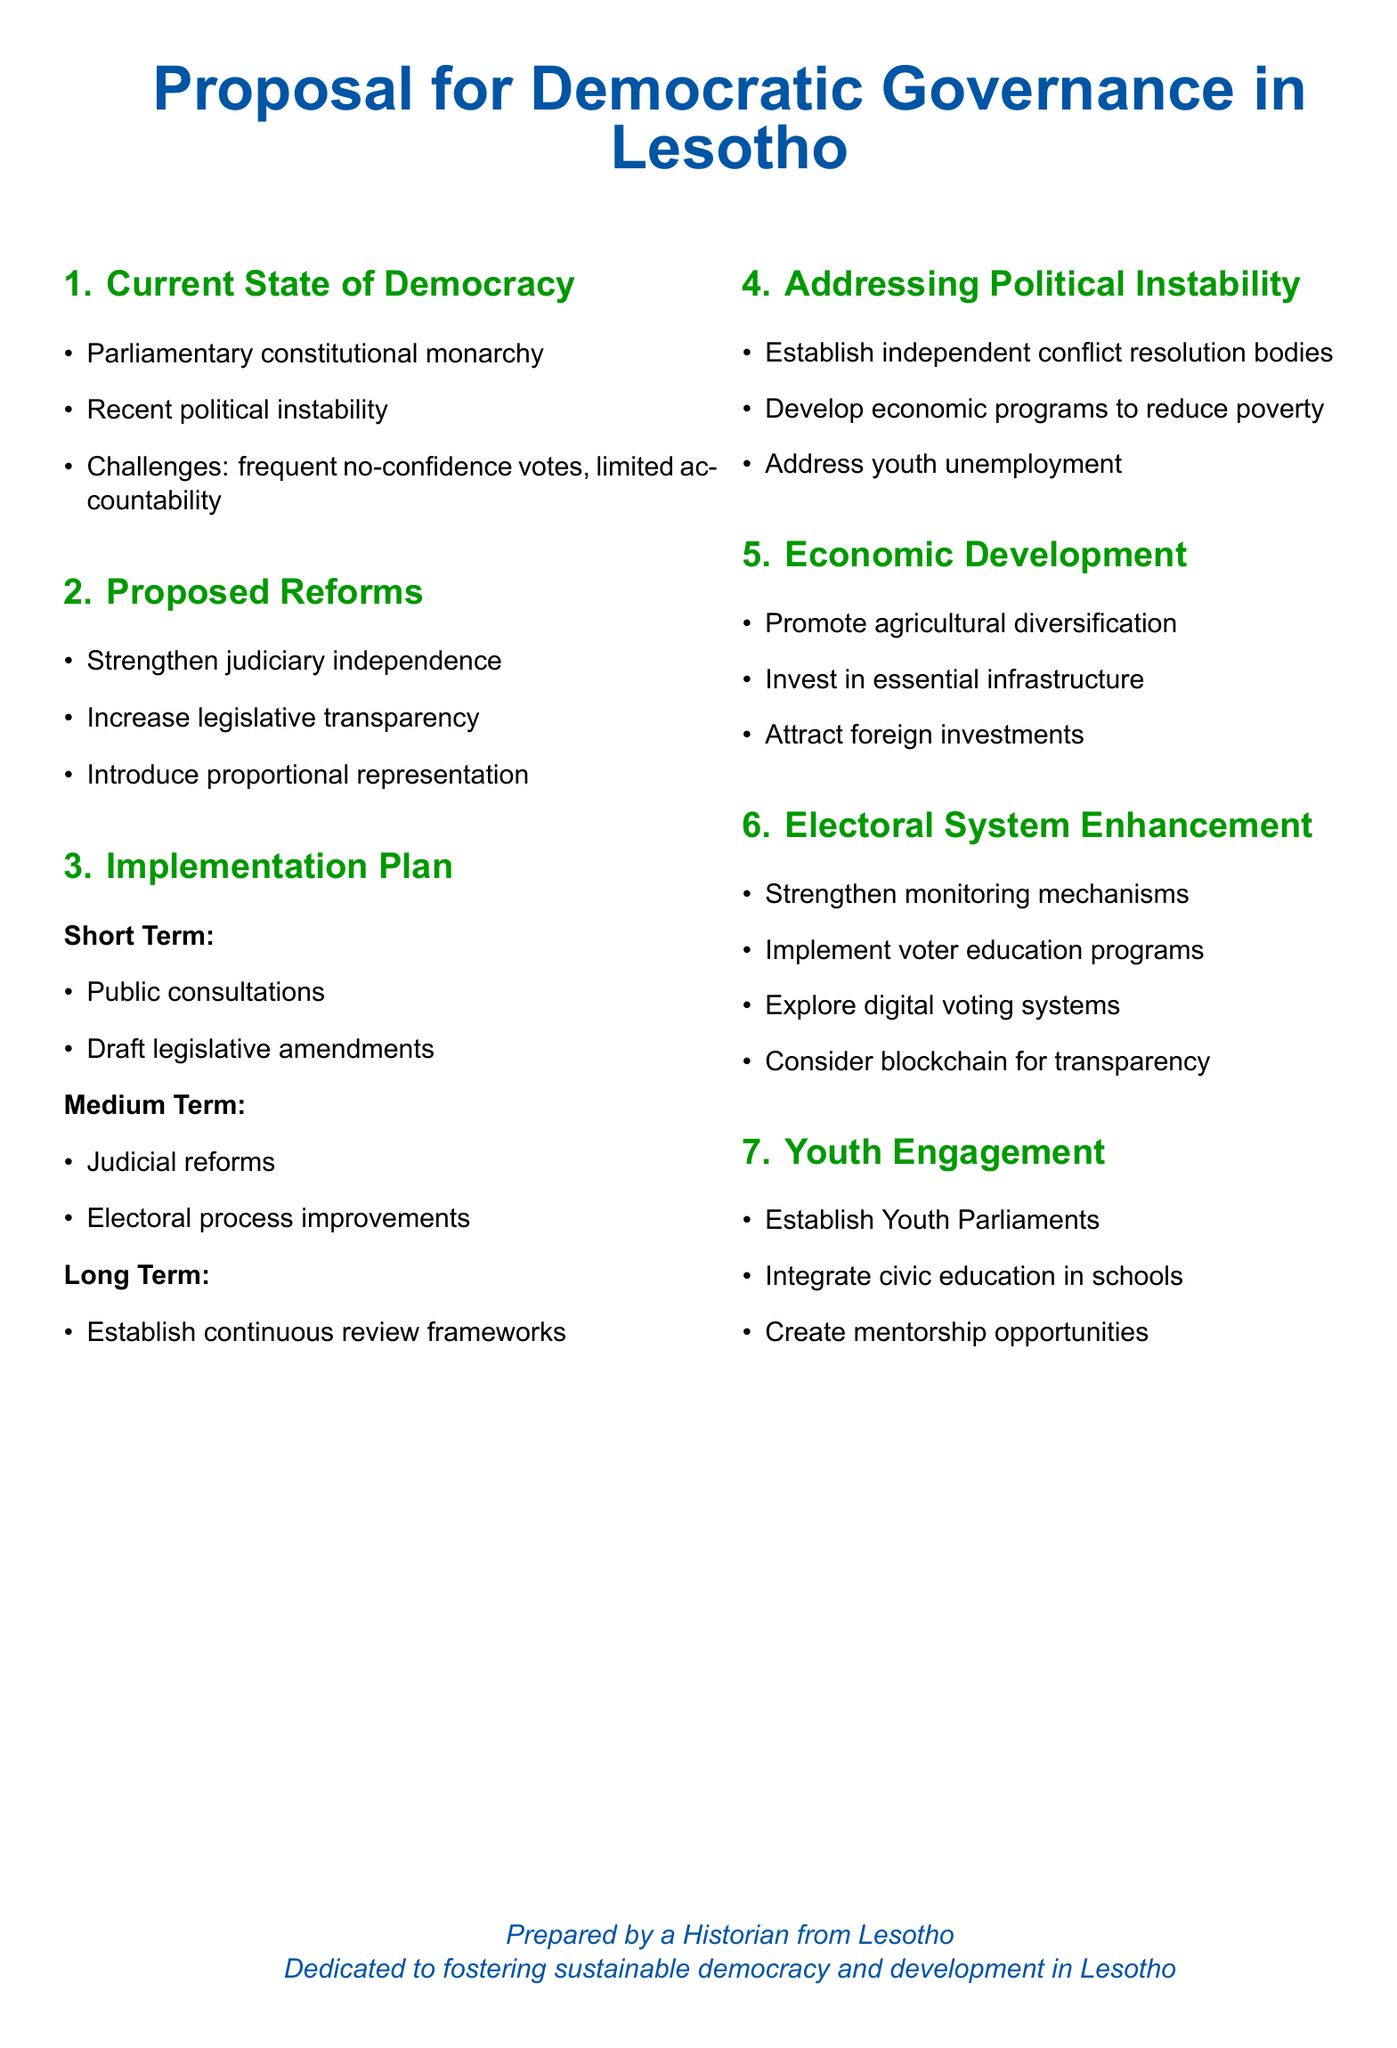what is the main title of the proposal? The main title is clearly stated at the beginning of the document.
Answer: Proposal for Democratic Governance in Lesotho how many sections are in the document? The sections are numbered in the document, and this can be counted easily.
Answer: Seven what is one proposed reform to improve governance? The reforms are listed under a dedicated section in the document.
Answer: Introduce proportional representation what is a strategy to address political instability? The strategies are clearly outlined in a specific section of the document.
Answer: Develop economic programs to reduce poverty what is one method suggested for enhancing the electoral system? The methods for enhancement are listed in a specific section of the document.
Answer: Implement voter education programs what is the target group for engagement mentioned in the document? The document specifies a particular group targeted for political engagement.
Answer: Youth what is one aspect of the short-term implementation plan? The short-term activities are enumerated within a specific time frame section in the document.
Answer: Public consultations what technology is suggested for improving electoral transparency? The document proposes an innovative approach for transparency in the electoral process.
Answer: Blockchain what is one barrier to youth participation in politics? While barriers are not specifically listed, the document implies challenges related to engagement.
Answer: Unemployment 